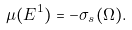Convert formula to latex. <formula><loc_0><loc_0><loc_500><loc_500>\mu ( E ^ { 1 } ) = - \sigma _ { s } ( \Omega ) .</formula> 